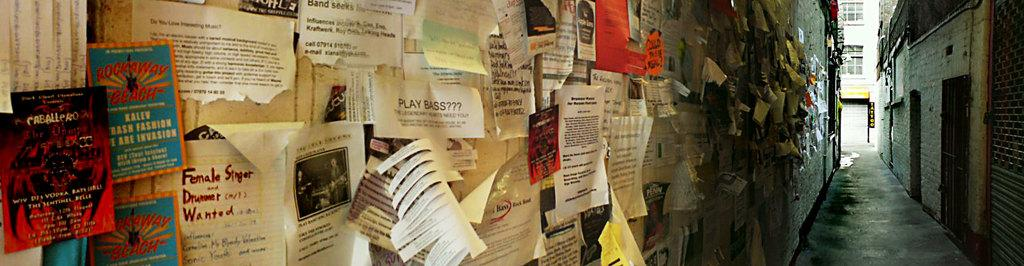What type of structures can be seen in the image? There are buildings in the image. What is attached to the walls of the buildings? Papers are attached to the walls in the image. Can you tell me how many women are present in the image? There is no woman present in the image; it only features buildings and papers attached to the walls. 